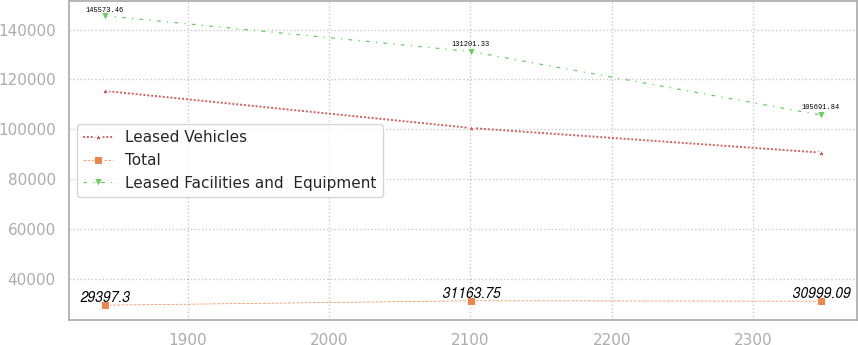<chart> <loc_0><loc_0><loc_500><loc_500><line_chart><ecel><fcel>Leased Vehicles<fcel>Total<fcel>Leased Facilities and  Equipment<nl><fcel>1841.13<fcel>115410<fcel>29397.3<fcel>145573<nl><fcel>2100.31<fcel>100519<fcel>31163.8<fcel>131201<nl><fcel>2348.23<fcel>90632.6<fcel>30999.1<fcel>105692<nl></chart> 